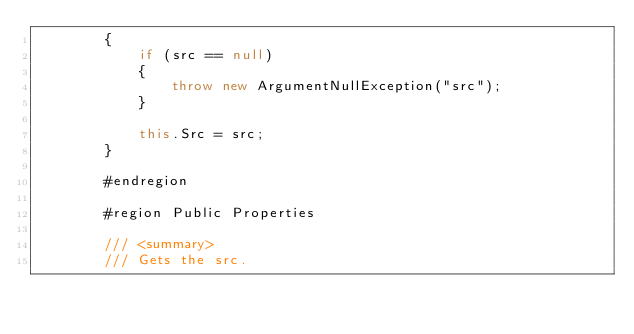Convert code to text. <code><loc_0><loc_0><loc_500><loc_500><_C#_>        {
            if (src == null)
            {
                throw new ArgumentNullException("src");
            }

            this.Src = src;
        }

        #endregion

        #region Public Properties

        /// <summary>
        /// Gets the src.</code> 